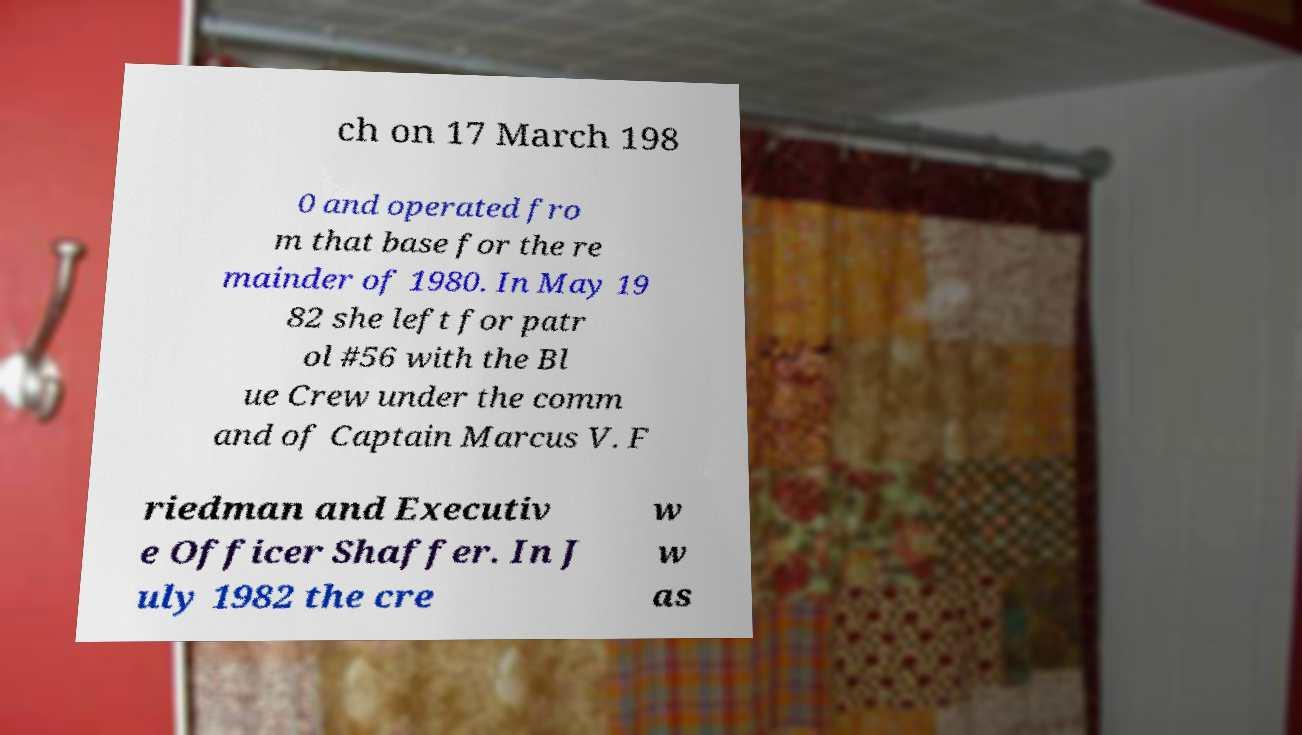For documentation purposes, I need the text within this image transcribed. Could you provide that? ch on 17 March 198 0 and operated fro m that base for the re mainder of 1980. In May 19 82 she left for patr ol #56 with the Bl ue Crew under the comm and of Captain Marcus V. F riedman and Executiv e Officer Shaffer. In J uly 1982 the cre w w as 